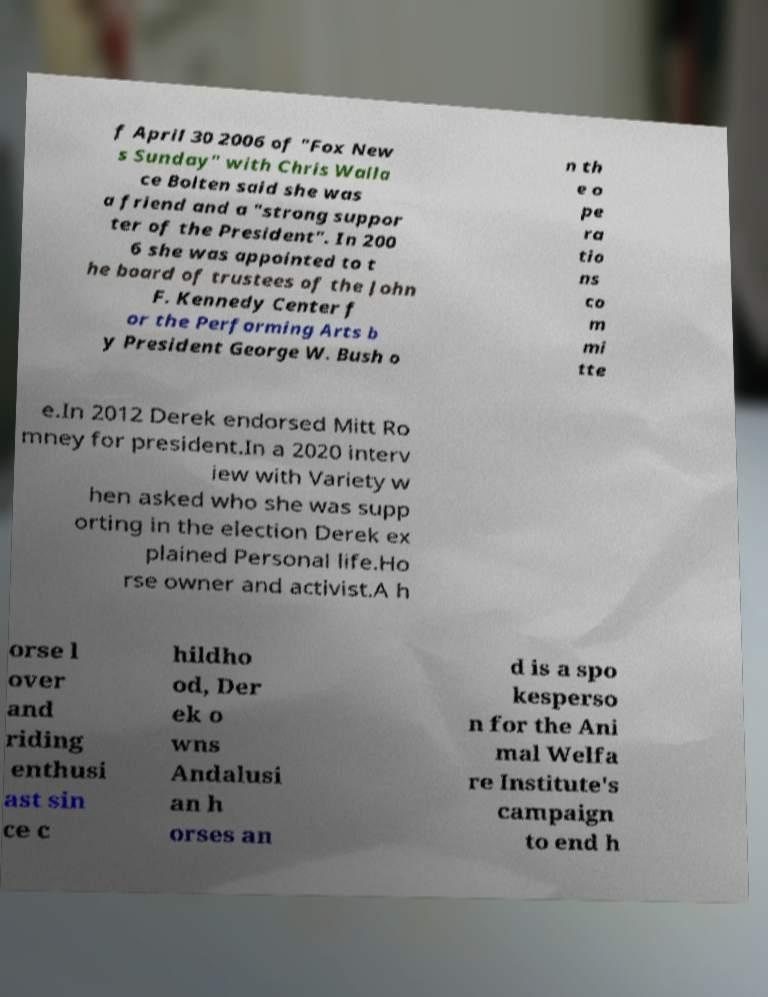Can you accurately transcribe the text from the provided image for me? f April 30 2006 of "Fox New s Sunday" with Chris Walla ce Bolten said she was a friend and a "strong suppor ter of the President". In 200 6 she was appointed to t he board of trustees of the John F. Kennedy Center f or the Performing Arts b y President George W. Bush o n th e o pe ra tio ns co m mi tte e.In 2012 Derek endorsed Mitt Ro mney for president.In a 2020 interv iew with Variety w hen asked who she was supp orting in the election Derek ex plained Personal life.Ho rse owner and activist.A h orse l over and riding enthusi ast sin ce c hildho od, Der ek o wns Andalusi an h orses an d is a spo kesperso n for the Ani mal Welfa re Institute's campaign to end h 